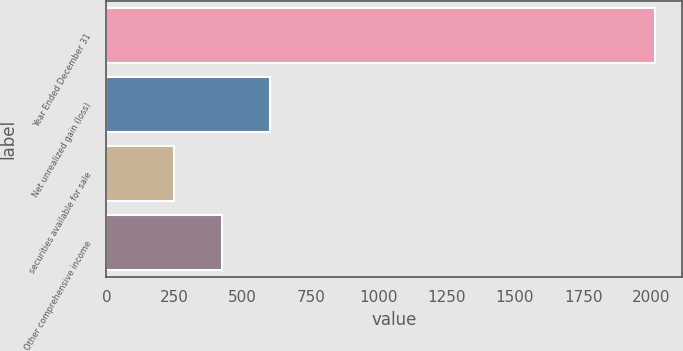<chart> <loc_0><loc_0><loc_500><loc_500><bar_chart><fcel>Year Ended December 31<fcel>Net unrealized gain (loss)<fcel>securities available for sale<fcel>Other comprehensive income<nl><fcel>2014<fcel>602<fcel>249<fcel>425.5<nl></chart> 